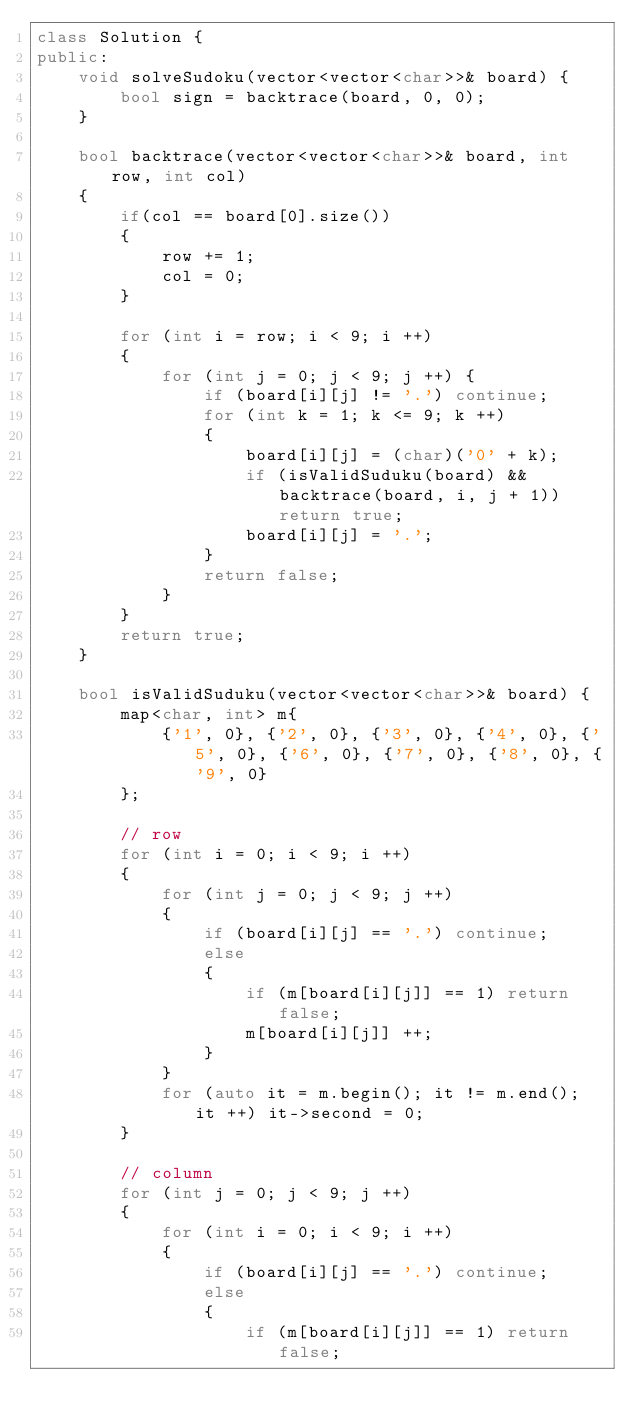Convert code to text. <code><loc_0><loc_0><loc_500><loc_500><_C++_>class Solution {
public:
    void solveSudoku(vector<vector<char>>& board) {
        bool sign = backtrace(board, 0, 0);
    }
    
    bool backtrace(vector<vector<char>>& board, int row, int col)
    {
        if(col == board[0].size())
        {
            row += 1;
            col = 0;
        }

        for (int i = row; i < 9; i ++)
        {
            for (int j = 0; j < 9; j ++) {
                if (board[i][j] != '.') continue;
                for (int k = 1; k <= 9; k ++)
                {
                    board[i][j] = (char)('0' + k);
                    if (isValidSuduku(board) && backtrace(board, i, j + 1)) return true;
                    board[i][j] = '.';
                }
                return false;
            }
        }
        return true;
    }
    
    bool isValidSuduku(vector<vector<char>>& board) {
        map<char, int> m{
            {'1', 0}, {'2', 0}, {'3', 0}, {'4', 0}, {'5', 0}, {'6', 0}, {'7', 0}, {'8', 0}, {'9', 0}
        };
        
        // row
        for (int i = 0; i < 9; i ++)
        {
            for (int j = 0; j < 9; j ++)
            {
                if (board[i][j] == '.') continue;
                else 
                {
                    if (m[board[i][j]] == 1) return false;
                    m[board[i][j]] ++;
                }
            }
            for (auto it = m.begin(); it != m.end(); it ++) it->second = 0;
        }
        
        // column
        for (int j = 0; j < 9; j ++)
        {
            for (int i = 0; i < 9; i ++)
            {
                if (board[i][j] == '.') continue;
                else 
                {
                    if (m[board[i][j]] == 1) return false;</code> 